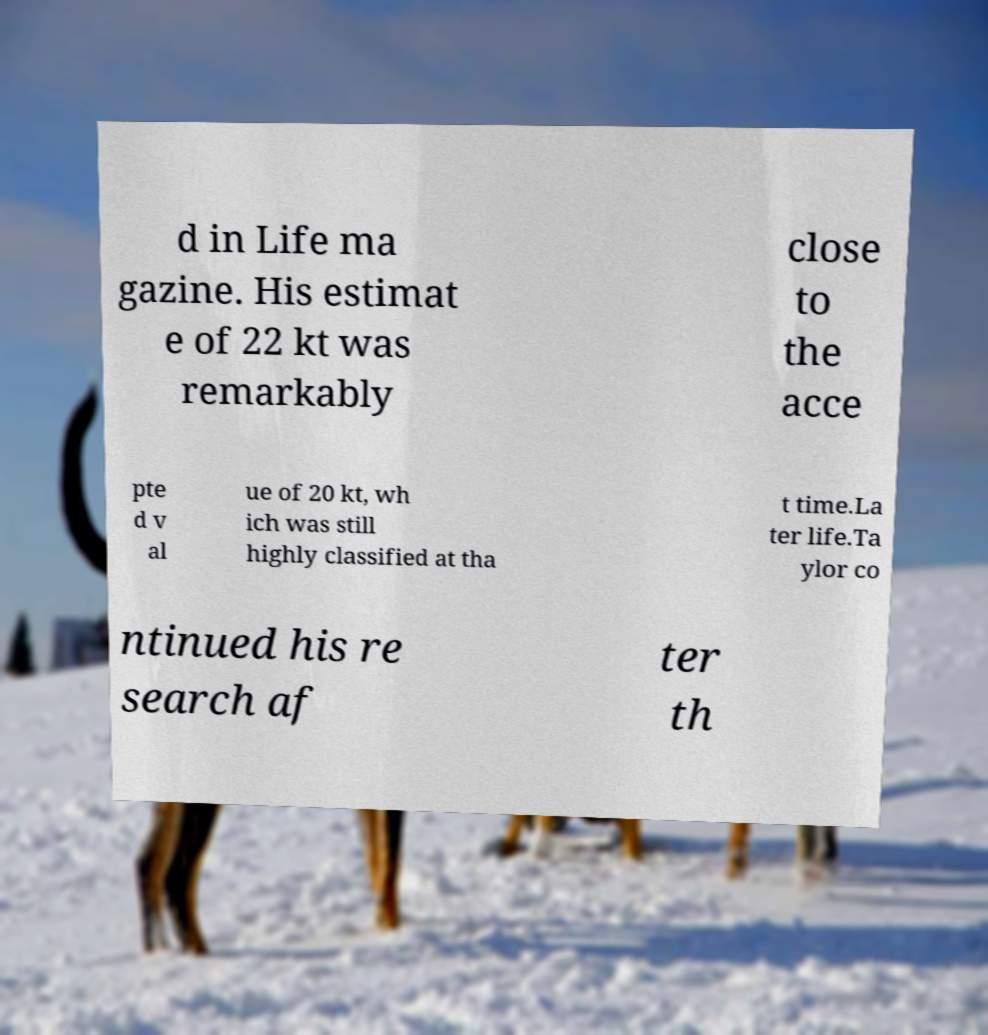Please read and relay the text visible in this image. What does it say? d in Life ma gazine. His estimat e of 22 kt was remarkably close to the acce pte d v al ue of 20 kt, wh ich was still highly classified at tha t time.La ter life.Ta ylor co ntinued his re search af ter th 